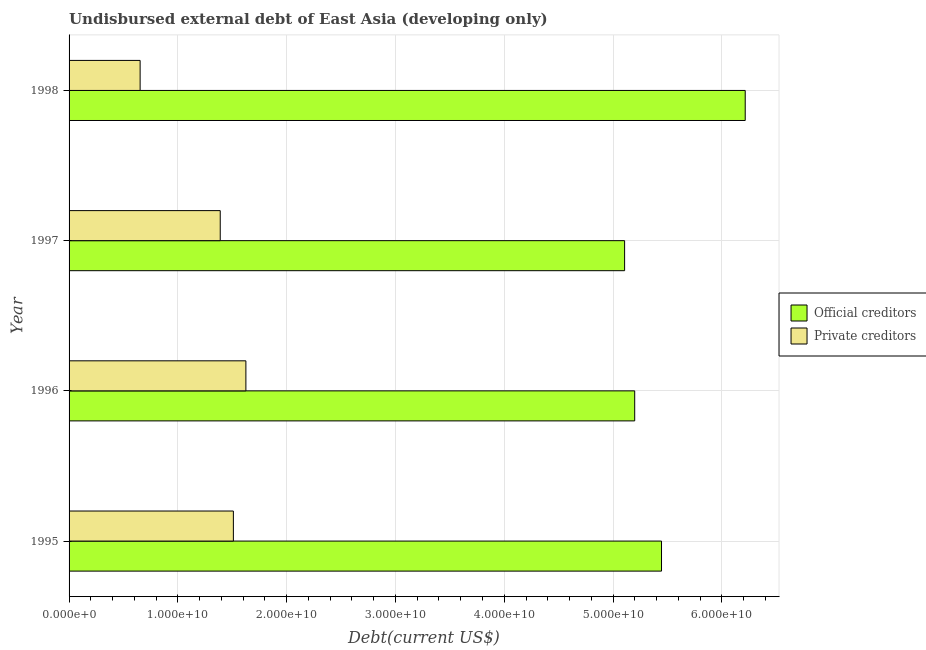How many groups of bars are there?
Keep it short and to the point. 4. How many bars are there on the 2nd tick from the top?
Your answer should be very brief. 2. What is the label of the 2nd group of bars from the top?
Ensure brevity in your answer.  1997. In how many cases, is the number of bars for a given year not equal to the number of legend labels?
Ensure brevity in your answer.  0. What is the undisbursed external debt of official creditors in 1997?
Provide a short and direct response. 5.11e+1. Across all years, what is the maximum undisbursed external debt of private creditors?
Give a very brief answer. 1.63e+1. Across all years, what is the minimum undisbursed external debt of private creditors?
Offer a very short reply. 6.53e+09. In which year was the undisbursed external debt of private creditors maximum?
Your answer should be very brief. 1996. What is the total undisbursed external debt of official creditors in the graph?
Ensure brevity in your answer.  2.20e+11. What is the difference between the undisbursed external debt of private creditors in 1996 and that in 1998?
Provide a succinct answer. 9.72e+09. What is the difference between the undisbursed external debt of official creditors in 1996 and the undisbursed external debt of private creditors in 1995?
Give a very brief answer. 3.69e+1. What is the average undisbursed external debt of private creditors per year?
Your answer should be very brief. 1.29e+1. In the year 1998, what is the difference between the undisbursed external debt of private creditors and undisbursed external debt of official creditors?
Offer a very short reply. -5.56e+1. In how many years, is the undisbursed external debt of private creditors greater than 42000000000 US$?
Your answer should be compact. 0. What is the ratio of the undisbursed external debt of official creditors in 1995 to that in 1997?
Your answer should be compact. 1.07. Is the undisbursed external debt of official creditors in 1995 less than that in 1996?
Provide a short and direct response. No. What is the difference between the highest and the second highest undisbursed external debt of official creditors?
Ensure brevity in your answer.  7.69e+09. What is the difference between the highest and the lowest undisbursed external debt of official creditors?
Give a very brief answer. 1.11e+1. In how many years, is the undisbursed external debt of official creditors greater than the average undisbursed external debt of official creditors taken over all years?
Make the answer very short. 1. What does the 2nd bar from the top in 1997 represents?
Your answer should be very brief. Official creditors. What does the 2nd bar from the bottom in 1997 represents?
Provide a short and direct response. Private creditors. What is the difference between two consecutive major ticks on the X-axis?
Your response must be concise. 1.00e+1. Does the graph contain grids?
Offer a terse response. Yes. How are the legend labels stacked?
Your answer should be compact. Vertical. What is the title of the graph?
Offer a terse response. Undisbursed external debt of East Asia (developing only). Does "Techinal cooperation" appear as one of the legend labels in the graph?
Ensure brevity in your answer.  No. What is the label or title of the X-axis?
Your answer should be compact. Debt(current US$). What is the Debt(current US$) of Official creditors in 1995?
Provide a succinct answer. 5.45e+1. What is the Debt(current US$) of Private creditors in 1995?
Give a very brief answer. 1.51e+1. What is the Debt(current US$) in Official creditors in 1996?
Your answer should be very brief. 5.20e+1. What is the Debt(current US$) in Private creditors in 1996?
Keep it short and to the point. 1.63e+1. What is the Debt(current US$) in Official creditors in 1997?
Your answer should be compact. 5.11e+1. What is the Debt(current US$) in Private creditors in 1997?
Your response must be concise. 1.39e+1. What is the Debt(current US$) in Official creditors in 1998?
Provide a short and direct response. 6.21e+1. What is the Debt(current US$) of Private creditors in 1998?
Your answer should be compact. 6.53e+09. Across all years, what is the maximum Debt(current US$) of Official creditors?
Ensure brevity in your answer.  6.21e+1. Across all years, what is the maximum Debt(current US$) in Private creditors?
Give a very brief answer. 1.63e+1. Across all years, what is the minimum Debt(current US$) of Official creditors?
Your answer should be compact. 5.11e+1. Across all years, what is the minimum Debt(current US$) in Private creditors?
Ensure brevity in your answer.  6.53e+09. What is the total Debt(current US$) of Official creditors in the graph?
Your response must be concise. 2.20e+11. What is the total Debt(current US$) in Private creditors in the graph?
Your response must be concise. 5.18e+1. What is the difference between the Debt(current US$) of Official creditors in 1995 and that in 1996?
Offer a very short reply. 2.47e+09. What is the difference between the Debt(current US$) of Private creditors in 1995 and that in 1996?
Make the answer very short. -1.15e+09. What is the difference between the Debt(current US$) in Official creditors in 1995 and that in 1997?
Provide a short and direct response. 3.39e+09. What is the difference between the Debt(current US$) in Private creditors in 1995 and that in 1997?
Provide a short and direct response. 1.21e+09. What is the difference between the Debt(current US$) of Official creditors in 1995 and that in 1998?
Your answer should be very brief. -7.69e+09. What is the difference between the Debt(current US$) in Private creditors in 1995 and that in 1998?
Give a very brief answer. 8.57e+09. What is the difference between the Debt(current US$) in Official creditors in 1996 and that in 1997?
Make the answer very short. 9.27e+08. What is the difference between the Debt(current US$) of Private creditors in 1996 and that in 1997?
Ensure brevity in your answer.  2.36e+09. What is the difference between the Debt(current US$) of Official creditors in 1996 and that in 1998?
Offer a terse response. -1.02e+1. What is the difference between the Debt(current US$) in Private creditors in 1996 and that in 1998?
Provide a short and direct response. 9.72e+09. What is the difference between the Debt(current US$) of Official creditors in 1997 and that in 1998?
Make the answer very short. -1.11e+1. What is the difference between the Debt(current US$) in Private creditors in 1997 and that in 1998?
Offer a very short reply. 7.36e+09. What is the difference between the Debt(current US$) in Official creditors in 1995 and the Debt(current US$) in Private creditors in 1996?
Ensure brevity in your answer.  3.82e+1. What is the difference between the Debt(current US$) of Official creditors in 1995 and the Debt(current US$) of Private creditors in 1997?
Your answer should be very brief. 4.06e+1. What is the difference between the Debt(current US$) in Official creditors in 1995 and the Debt(current US$) in Private creditors in 1998?
Make the answer very short. 4.79e+1. What is the difference between the Debt(current US$) in Official creditors in 1996 and the Debt(current US$) in Private creditors in 1997?
Your answer should be very brief. 3.81e+1. What is the difference between the Debt(current US$) in Official creditors in 1996 and the Debt(current US$) in Private creditors in 1998?
Ensure brevity in your answer.  4.55e+1. What is the difference between the Debt(current US$) of Official creditors in 1997 and the Debt(current US$) of Private creditors in 1998?
Your answer should be compact. 4.45e+1. What is the average Debt(current US$) in Official creditors per year?
Ensure brevity in your answer.  5.49e+1. What is the average Debt(current US$) in Private creditors per year?
Give a very brief answer. 1.29e+1. In the year 1995, what is the difference between the Debt(current US$) in Official creditors and Debt(current US$) in Private creditors?
Your response must be concise. 3.94e+1. In the year 1996, what is the difference between the Debt(current US$) of Official creditors and Debt(current US$) of Private creditors?
Make the answer very short. 3.57e+1. In the year 1997, what is the difference between the Debt(current US$) in Official creditors and Debt(current US$) in Private creditors?
Keep it short and to the point. 3.72e+1. In the year 1998, what is the difference between the Debt(current US$) in Official creditors and Debt(current US$) in Private creditors?
Offer a very short reply. 5.56e+1. What is the ratio of the Debt(current US$) in Official creditors in 1995 to that in 1996?
Give a very brief answer. 1.05. What is the ratio of the Debt(current US$) in Private creditors in 1995 to that in 1996?
Offer a terse response. 0.93. What is the ratio of the Debt(current US$) in Official creditors in 1995 to that in 1997?
Offer a very short reply. 1.07. What is the ratio of the Debt(current US$) in Private creditors in 1995 to that in 1997?
Your answer should be compact. 1.09. What is the ratio of the Debt(current US$) of Official creditors in 1995 to that in 1998?
Your answer should be very brief. 0.88. What is the ratio of the Debt(current US$) of Private creditors in 1995 to that in 1998?
Make the answer very short. 2.31. What is the ratio of the Debt(current US$) of Official creditors in 1996 to that in 1997?
Provide a succinct answer. 1.02. What is the ratio of the Debt(current US$) in Private creditors in 1996 to that in 1997?
Provide a succinct answer. 1.17. What is the ratio of the Debt(current US$) in Official creditors in 1996 to that in 1998?
Offer a terse response. 0.84. What is the ratio of the Debt(current US$) in Private creditors in 1996 to that in 1998?
Your response must be concise. 2.49. What is the ratio of the Debt(current US$) of Official creditors in 1997 to that in 1998?
Offer a terse response. 0.82. What is the ratio of the Debt(current US$) in Private creditors in 1997 to that in 1998?
Ensure brevity in your answer.  2.13. What is the difference between the highest and the second highest Debt(current US$) in Official creditors?
Your answer should be compact. 7.69e+09. What is the difference between the highest and the second highest Debt(current US$) in Private creditors?
Your response must be concise. 1.15e+09. What is the difference between the highest and the lowest Debt(current US$) in Official creditors?
Offer a terse response. 1.11e+1. What is the difference between the highest and the lowest Debt(current US$) in Private creditors?
Give a very brief answer. 9.72e+09. 